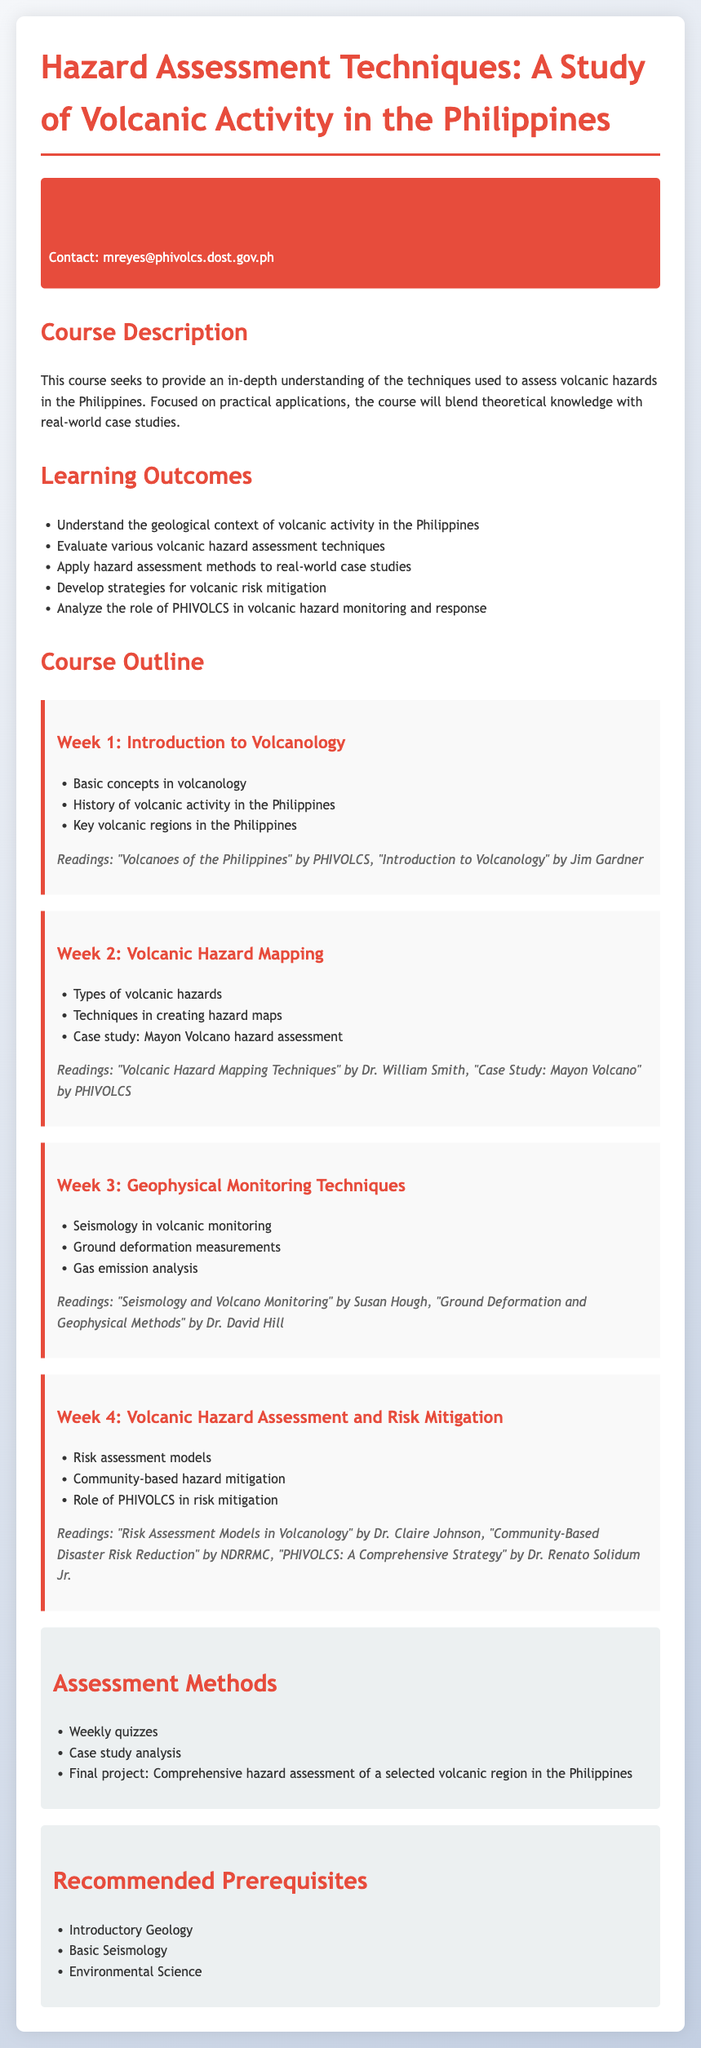What is the course title? The course title is clearly stated at the beginning of the document.
Answer: Hazard Assessment Techniques: A Study of Volcanic Activity in the Philippines Who is the instructor? The information about the instructor is provided in the instructor info section.
Answer: Dr. Mina Reyes What is one of the learning outcomes? The document lists multiple learning outcomes related to volcanic hazard assessment techniques.
Answer: Understand the geological context of volcanic activity in the Philippines How many weeks is the course outline? The course outline section details the topics over multiple weeks.
Answer: 4 What technique is taught in Week 2? Week 2's content focuses on specialized techniques in a specific aspect of volcanic risk.
Answer: Hazard Mapping What is one of the recommended prerequisites? The prerequisites are listed in a dedicated section in the syllabus.
Answer: Introductory Geology What type of assessment is included in the course? Assessments are mentioned under a specific section related to evaluation methods in the syllabus.
Answer: Weekly quizzes Which volcano is the case study focused on in Week 2? Week 2 specifically mentions a well-known volcano for the hazard assessment case study.
Answer: Mayon Volcano What is the email address of the instructor? The contact information for the instructor is included in the instructor info section.
Answer: mreyes@phivolcs.dost.gov.ph 